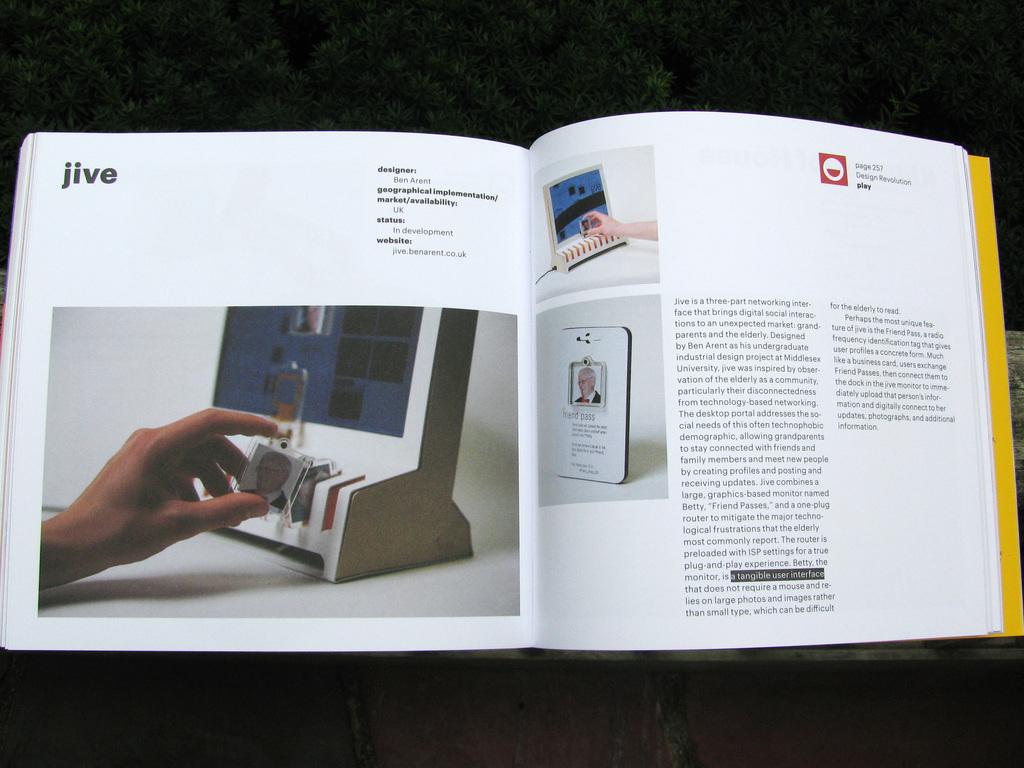What is this book about?
Your response must be concise. Jive. What word is in the upper left corner of the left page?
Your answer should be very brief. Jive. 